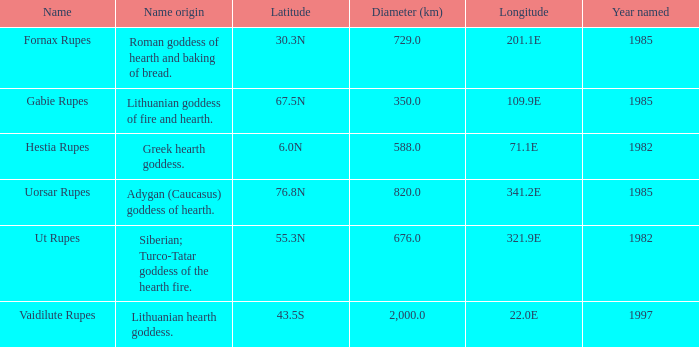Parse the table in full. {'header': ['Name', 'Name origin', 'Latitude', 'Diameter (km)', 'Longitude', 'Year named'], 'rows': [['Fornax Rupes', 'Roman goddess of hearth and baking of bread.', '30.3N', '729.0', '201.1E', '1985'], ['Gabie Rupes', 'Lithuanian goddess of fire and hearth.', '67.5N', '350.0', '109.9E', '1985'], ['Hestia Rupes', 'Greek hearth goddess.', '6.0N', '588.0', '71.1E', '1982'], ['Uorsar Rupes', 'Adygan (Caucasus) goddess of hearth.', '76.8N', '820.0', '341.2E', '1985'], ['Ut Rupes', 'Siberian; Turco-Tatar goddess of the hearth fire.', '55.3N', '676.0', '321.9E', '1982'], ['Vaidilute Rupes', 'Lithuanian hearth goddess.', '43.5S', '2,000.0', '22.0E', '1997']]} At a longitude of 321.9e, what is the latitude of the features found? 55.3N. 